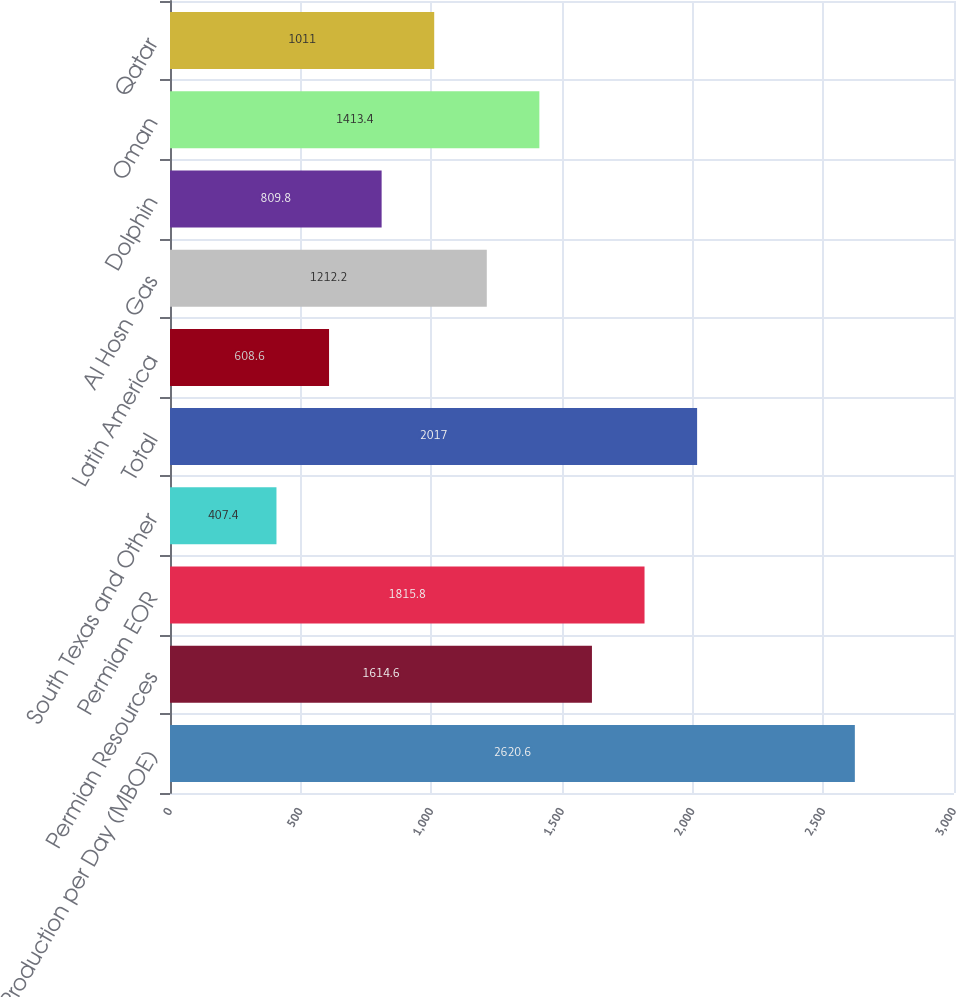Convert chart to OTSL. <chart><loc_0><loc_0><loc_500><loc_500><bar_chart><fcel>Production per Day (MBOE)<fcel>Permian Resources<fcel>Permian EOR<fcel>South Texas and Other<fcel>Total<fcel>Latin America<fcel>Al Hosn Gas<fcel>Dolphin<fcel>Oman<fcel>Qatar<nl><fcel>2620.6<fcel>1614.6<fcel>1815.8<fcel>407.4<fcel>2017<fcel>608.6<fcel>1212.2<fcel>809.8<fcel>1413.4<fcel>1011<nl></chart> 